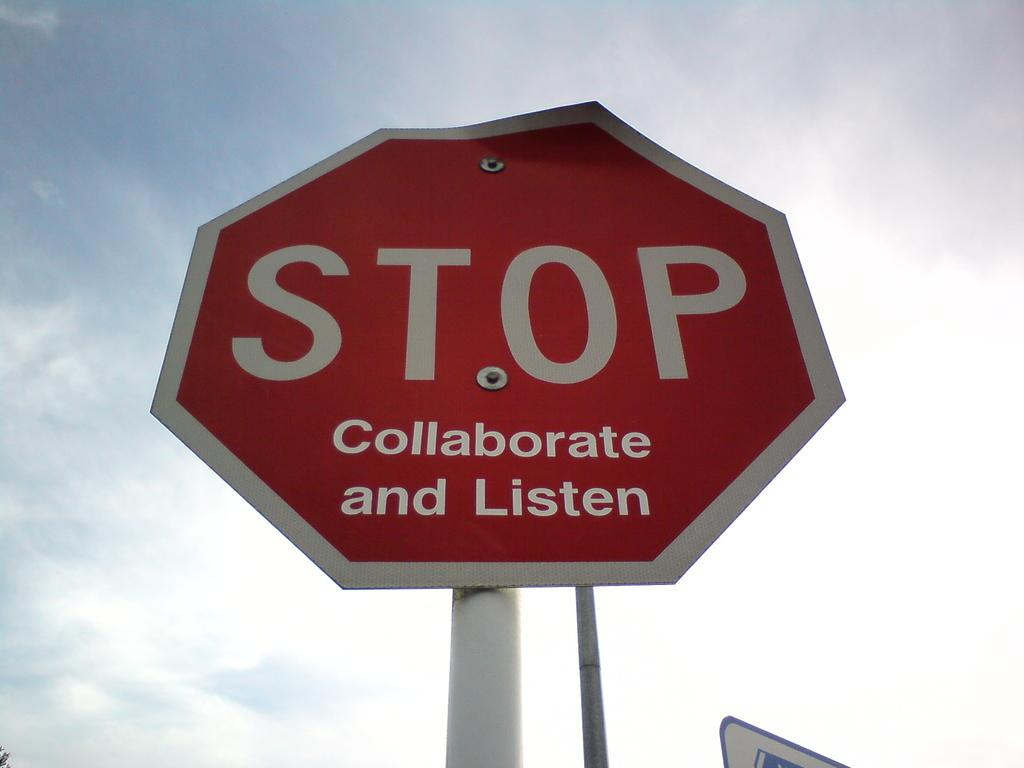What is the main object in the image? There is a STOP sign board in the image. How is the sign board positioned in the image? The sign board is on a pole. What is the condition of the sky in the image? The sky is cloudy in the image. What type of marble can be seen on the ground in the image? There is no marble visible on the ground in the image; it only features a STOP sign board on a pole and a cloudy sky. How does the beginner learn to use the whip in the image? There is no whip or any indication of learning in the image; it only features a STOP sign board on a pole and a cloudy sky. 